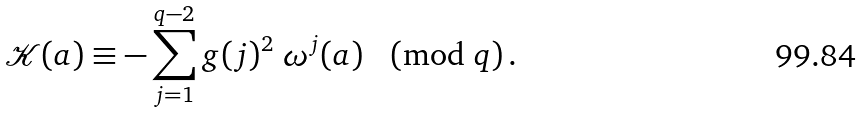Convert formula to latex. <formula><loc_0><loc_0><loc_500><loc_500>\mathcal { K } ( a ) \equiv - \sum _ { j = 1 } ^ { q - 2 } g ( j ) ^ { 2 } \ \omega ^ { j } ( a ) \pmod { q } \, .</formula> 